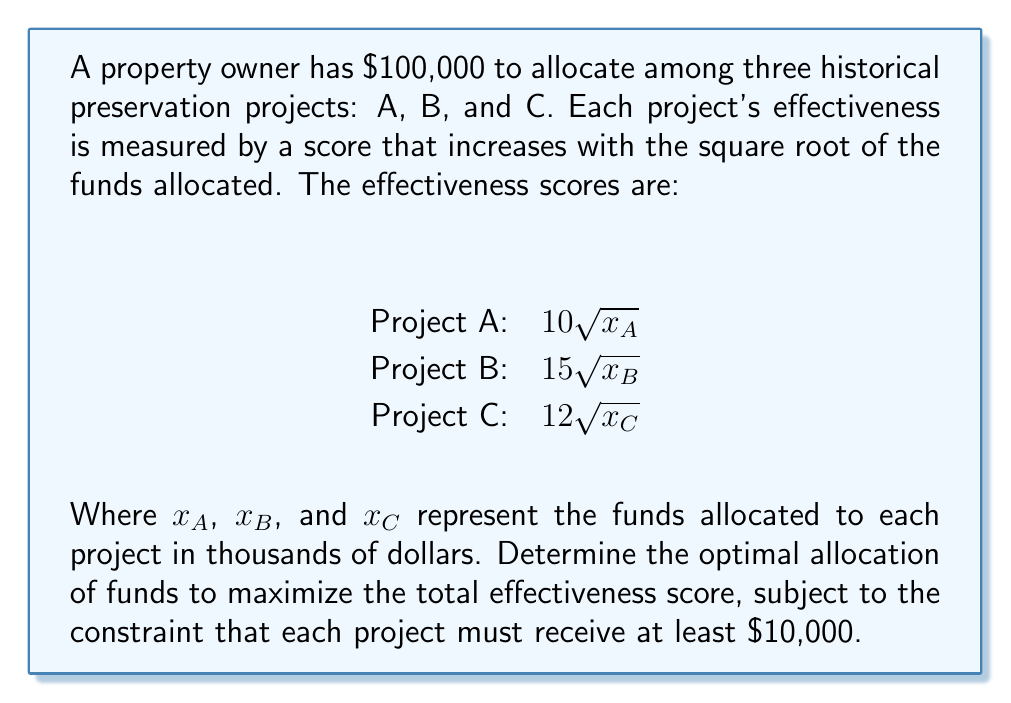Show me your answer to this math problem. To solve this optimization problem, we'll use the method of Lagrange multipliers:

1) Define the objective function:
   $$f(x_A, x_B, x_C) = 10\sqrt{x_A} + 15\sqrt{x_B} + 12\sqrt{x_C}$$

2) Define the constraint:
   $$g(x_A, x_B, x_C) = x_A + x_B + x_C - 100 = 0$$

3) Form the Lagrangian:
   $$L(x_A, x_B, x_C, \lambda) = 10\sqrt{x_A} + 15\sqrt{x_B} + 12\sqrt{x_C} - \lambda(x_A + x_B + x_C - 100)$$

4) Take partial derivatives and set them equal to zero:
   $$\frac{\partial L}{\partial x_A} = \frac{5}{\sqrt{x_A}} - \lambda = 0$$
   $$\frac{\partial L}{\partial x_B} = \frac{15}{2\sqrt{x_B}} - \lambda = 0$$
   $$\frac{\partial L}{\partial x_C} = \frac{6}{\sqrt{x_C}} - \lambda = 0$$
   $$\frac{\partial L}{\partial \lambda} = x_A + x_B + x_C - 100 = 0$$

5) From these equations, we can deduce:
   $$\frac{5}{\sqrt{x_A}} = \frac{15}{2\sqrt{x_B}} = \frac{6}{\sqrt{x_C}}$$

6) This implies:
   $$x_B = \frac{9}{4}x_A \text{ and } x_C = \frac{36}{25}x_A$$

7) Substituting into the constraint equation:
   $$x_A + \frac{9}{4}x_A + \frac{36}{25}x_A = 100$$
   $$\frac{100}{25}x_A + \frac{225}{100}x_A + \frac{144}{100}x_A = 100$$
   $$\frac{469}{100}x_A = 100$$
   $$x_A = \frac{10000}{469} \approx 21.32$$

8) Therefore:
   $$x_B = \frac{9}{4} \cdot \frac{10000}{469} \approx 47.97$$
   $$x_C = \frac{36}{25} \cdot \frac{10000}{469} \approx 30.71$$

9) Check the constraint that each project receives at least $10,000:
   All allocations are above $10,000, so this constraint is satisfied.

Thus, the optimal allocation is approximately:
Project A: $21,320
Project B: $47,970
Project C: $30,710
Answer: The optimal allocation to maximize the total effectiveness score is:
Project A: $21,320
Project B: $47,970
Project C: $30,710 